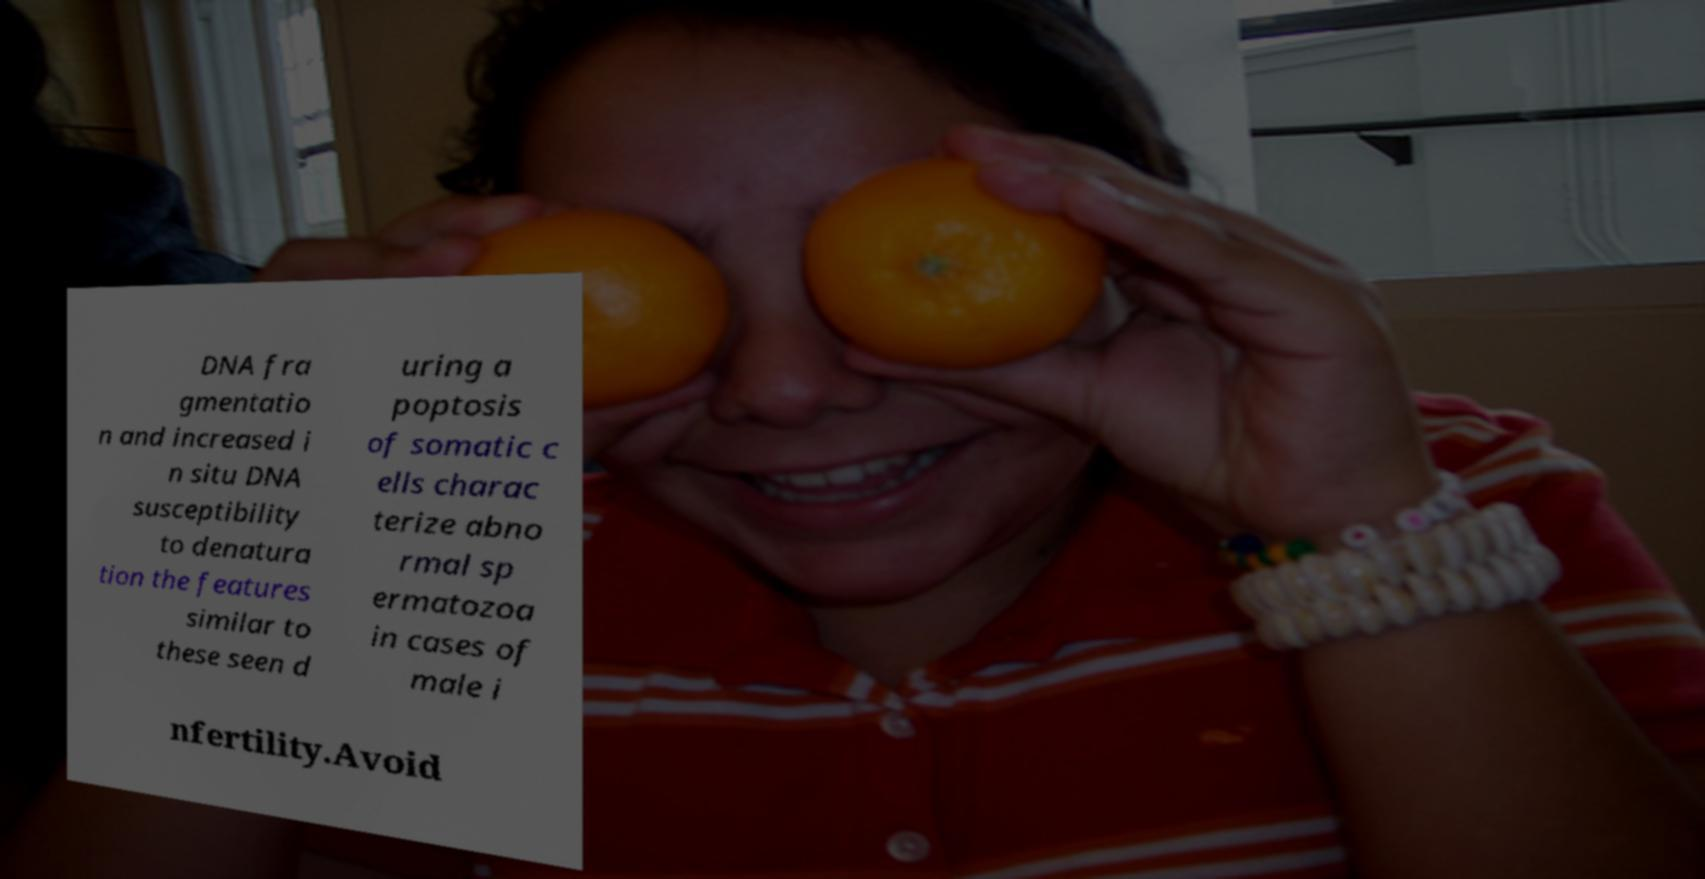Please identify and transcribe the text found in this image. DNA fra gmentatio n and increased i n situ DNA susceptibility to denatura tion the features similar to these seen d uring a poptosis of somatic c ells charac terize abno rmal sp ermatozoa in cases of male i nfertility.Avoid 